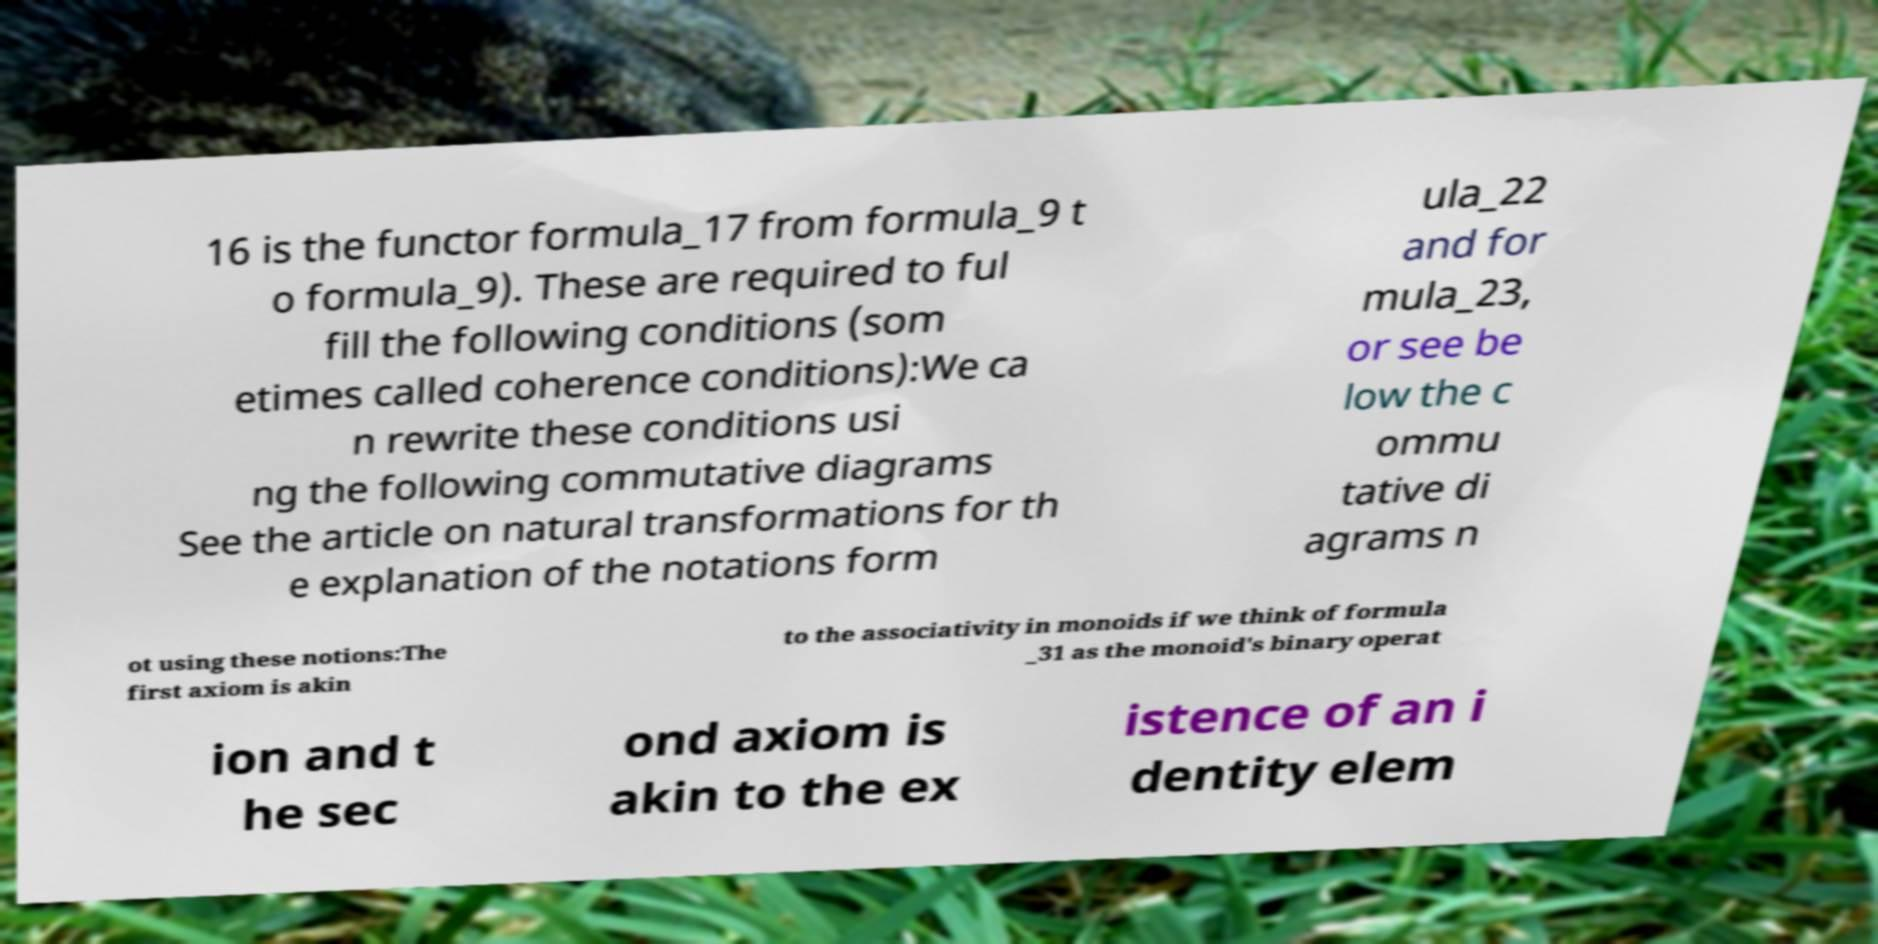Please read and relay the text visible in this image. What does it say? 16 is the functor formula_17 from formula_9 t o formula_9). These are required to ful fill the following conditions (som etimes called coherence conditions):We ca n rewrite these conditions usi ng the following commutative diagrams See the article on natural transformations for th e explanation of the notations form ula_22 and for mula_23, or see be low the c ommu tative di agrams n ot using these notions:The first axiom is akin to the associativity in monoids if we think of formula _31 as the monoid's binary operat ion and t he sec ond axiom is akin to the ex istence of an i dentity elem 